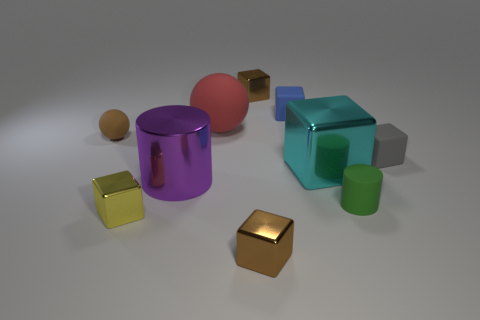Subtract all gray matte cubes. How many cubes are left? 5 Subtract all gray spheres. How many brown blocks are left? 2 Subtract all gray cubes. How many cubes are left? 5 Subtract 4 cubes. How many cubes are left? 2 Subtract 1 purple cylinders. How many objects are left? 9 Subtract all spheres. How many objects are left? 8 Subtract all yellow cubes. Subtract all brown spheres. How many cubes are left? 5 Subtract all green matte objects. Subtract all tiny gray blocks. How many objects are left? 8 Add 1 red things. How many red things are left? 2 Add 8 green objects. How many green objects exist? 9 